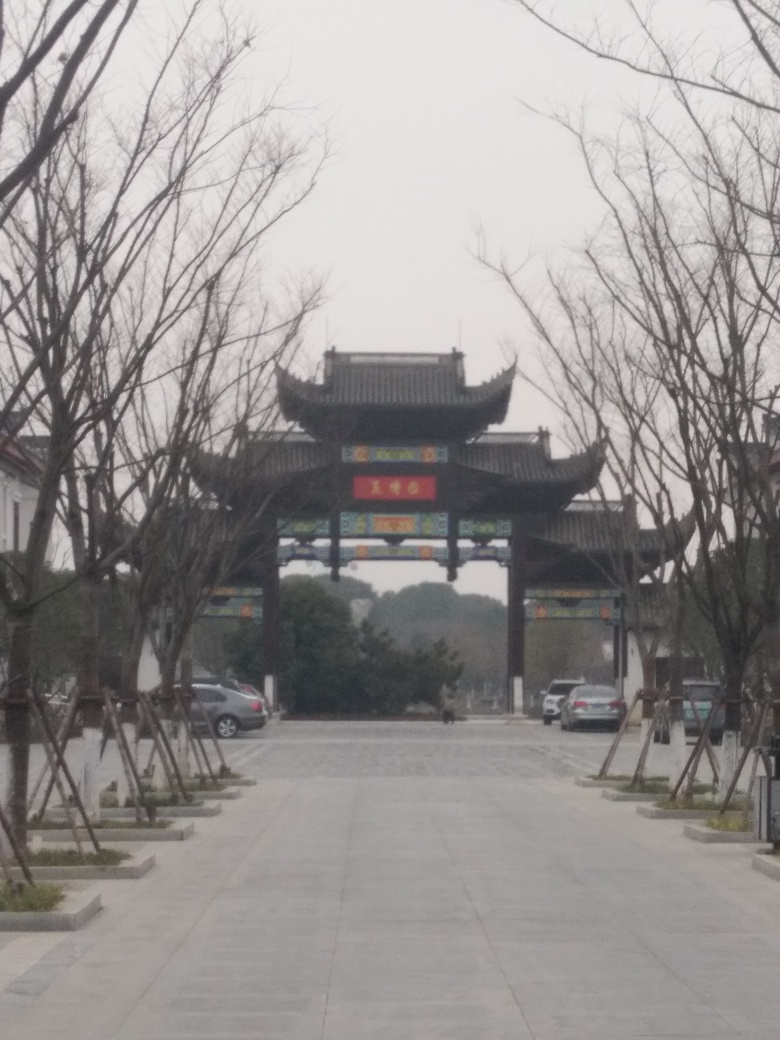What is the overall clarity of this image? The clarity of the image is relatively low. It appears somewhat blurry and lacks sharpness, which could be due to a low-resolution camera or camera shake. This obscures finer details in the scene, such as the texture of the trees and the architectural details of the gate structure in the background. 